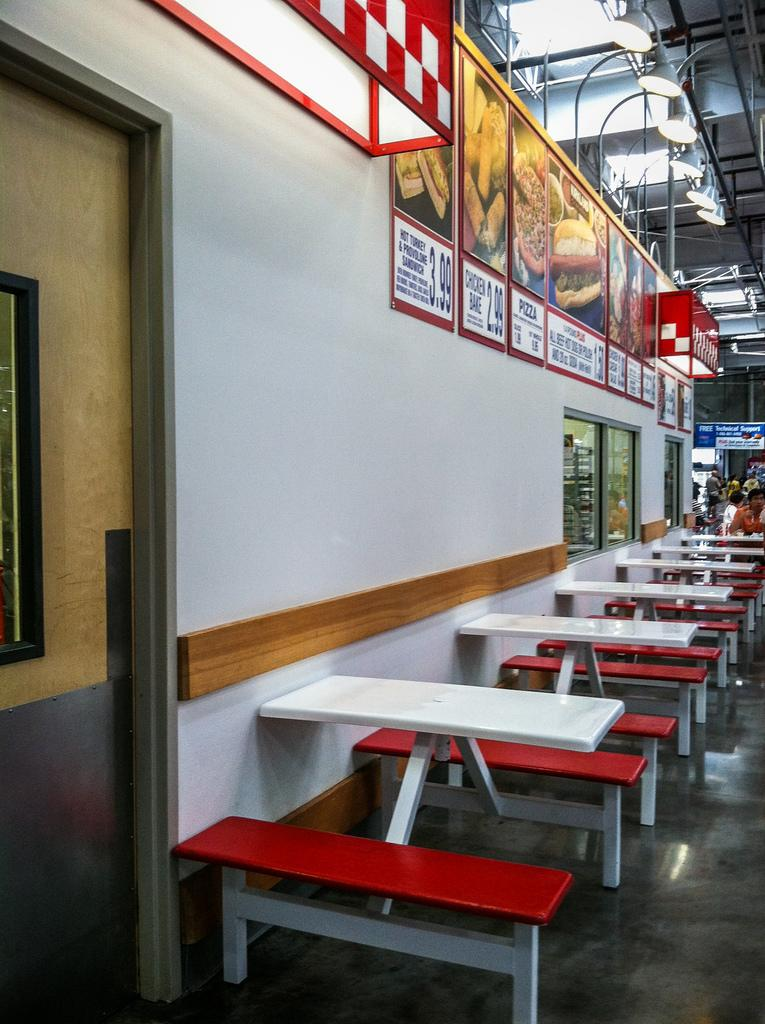What type of seating is present in the image? There are benches in the image. Who or what can be seen in the image? There are people in the image. Where is the door located in the image? The door is on the left side of the image. What can be seen in the background of the image? There are boards visible in the background of the image. What is illuminating the area in the image? There are lights at the top of the image. What type of guitar is being played by the people in the image? There is no guitar present in the image; it features benches, people, a door, boards, and lights. What is the title of the science experiment being conducted in the image? There is no science experiment or title present in the image. 